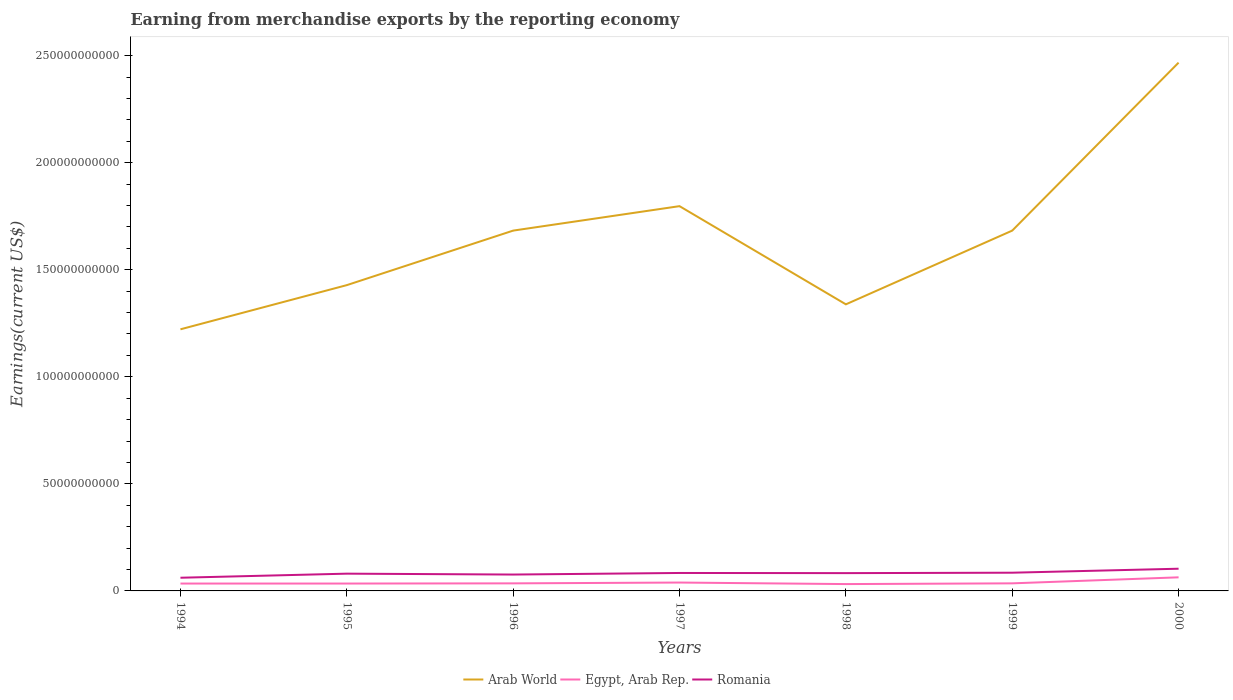How many different coloured lines are there?
Give a very brief answer. 3. Is the number of lines equal to the number of legend labels?
Give a very brief answer. Yes. Across all years, what is the maximum amount earned from merchandise exports in Romania?
Keep it short and to the point. 6.16e+09. In which year was the amount earned from merchandise exports in Arab World maximum?
Offer a very short reply. 1994. What is the total amount earned from merchandise exports in Romania in the graph?
Your answer should be very brief. -6.70e+08. What is the difference between the highest and the second highest amount earned from merchandise exports in Romania?
Offer a very short reply. 4.21e+09. Is the amount earned from merchandise exports in Romania strictly greater than the amount earned from merchandise exports in Arab World over the years?
Keep it short and to the point. Yes. How many years are there in the graph?
Your response must be concise. 7. Does the graph contain any zero values?
Your response must be concise. No. What is the title of the graph?
Your answer should be very brief. Earning from merchandise exports by the reporting economy. What is the label or title of the X-axis?
Offer a terse response. Years. What is the label or title of the Y-axis?
Provide a short and direct response. Earnings(current US$). What is the Earnings(current US$) of Arab World in 1994?
Your answer should be compact. 1.22e+11. What is the Earnings(current US$) of Egypt, Arab Rep. in 1994?
Offer a very short reply. 3.45e+09. What is the Earnings(current US$) in Romania in 1994?
Your answer should be compact. 6.16e+09. What is the Earnings(current US$) of Arab World in 1995?
Your answer should be compact. 1.43e+11. What is the Earnings(current US$) in Egypt, Arab Rep. in 1995?
Ensure brevity in your answer.  3.44e+09. What is the Earnings(current US$) of Romania in 1995?
Give a very brief answer. 8.06e+09. What is the Earnings(current US$) in Arab World in 1996?
Provide a succinct answer. 1.68e+11. What is the Earnings(current US$) of Egypt, Arab Rep. in 1996?
Your response must be concise. 3.53e+09. What is the Earnings(current US$) in Romania in 1996?
Keep it short and to the point. 7.64e+09. What is the Earnings(current US$) in Arab World in 1997?
Keep it short and to the point. 1.80e+11. What is the Earnings(current US$) in Egypt, Arab Rep. in 1997?
Offer a terse response. 3.91e+09. What is the Earnings(current US$) of Romania in 1997?
Offer a very short reply. 8.39e+09. What is the Earnings(current US$) of Arab World in 1998?
Keep it short and to the point. 1.34e+11. What is the Earnings(current US$) in Egypt, Arab Rep. in 1998?
Provide a short and direct response. 3.20e+09. What is the Earnings(current US$) of Romania in 1998?
Keep it short and to the point. 8.31e+09. What is the Earnings(current US$) of Arab World in 1999?
Offer a very short reply. 1.68e+11. What is the Earnings(current US$) of Egypt, Arab Rep. in 1999?
Your answer should be very brief. 3.54e+09. What is the Earnings(current US$) of Romania in 1999?
Keep it short and to the point. 8.51e+09. What is the Earnings(current US$) in Arab World in 2000?
Your answer should be compact. 2.47e+11. What is the Earnings(current US$) in Egypt, Arab Rep. in 2000?
Keep it short and to the point. 6.35e+09. What is the Earnings(current US$) in Romania in 2000?
Give a very brief answer. 1.04e+1. Across all years, what is the maximum Earnings(current US$) of Arab World?
Offer a terse response. 2.47e+11. Across all years, what is the maximum Earnings(current US$) in Egypt, Arab Rep.?
Your answer should be very brief. 6.35e+09. Across all years, what is the maximum Earnings(current US$) of Romania?
Provide a short and direct response. 1.04e+1. Across all years, what is the minimum Earnings(current US$) in Arab World?
Make the answer very short. 1.22e+11. Across all years, what is the minimum Earnings(current US$) of Egypt, Arab Rep.?
Keep it short and to the point. 3.20e+09. Across all years, what is the minimum Earnings(current US$) of Romania?
Ensure brevity in your answer.  6.16e+09. What is the total Earnings(current US$) in Arab World in the graph?
Offer a terse response. 1.16e+12. What is the total Earnings(current US$) of Egypt, Arab Rep. in the graph?
Provide a succinct answer. 2.74e+1. What is the total Earnings(current US$) in Romania in the graph?
Give a very brief answer. 5.74e+1. What is the difference between the Earnings(current US$) of Arab World in 1994 and that in 1995?
Provide a short and direct response. -2.06e+1. What is the difference between the Earnings(current US$) in Egypt, Arab Rep. in 1994 and that in 1995?
Provide a succinct answer. 3.36e+06. What is the difference between the Earnings(current US$) in Romania in 1994 and that in 1995?
Provide a short and direct response. -1.90e+09. What is the difference between the Earnings(current US$) of Arab World in 1994 and that in 1996?
Your answer should be compact. -4.61e+1. What is the difference between the Earnings(current US$) in Egypt, Arab Rep. in 1994 and that in 1996?
Provide a succinct answer. -8.70e+07. What is the difference between the Earnings(current US$) of Romania in 1994 and that in 1996?
Make the answer very short. -1.48e+09. What is the difference between the Earnings(current US$) of Arab World in 1994 and that in 1997?
Offer a terse response. -5.75e+1. What is the difference between the Earnings(current US$) in Egypt, Arab Rep. in 1994 and that in 1997?
Keep it short and to the point. -4.60e+08. What is the difference between the Earnings(current US$) of Romania in 1994 and that in 1997?
Make the answer very short. -2.23e+09. What is the difference between the Earnings(current US$) in Arab World in 1994 and that in 1998?
Offer a very short reply. -1.17e+1. What is the difference between the Earnings(current US$) of Egypt, Arab Rep. in 1994 and that in 1998?
Make the answer very short. 2.52e+08. What is the difference between the Earnings(current US$) in Romania in 1994 and that in 1998?
Ensure brevity in your answer.  -2.15e+09. What is the difference between the Earnings(current US$) in Arab World in 1994 and that in 1999?
Your answer should be very brief. -4.61e+1. What is the difference between the Earnings(current US$) of Egypt, Arab Rep. in 1994 and that in 1999?
Provide a short and direct response. -8.83e+07. What is the difference between the Earnings(current US$) in Romania in 1994 and that in 1999?
Your answer should be compact. -2.35e+09. What is the difference between the Earnings(current US$) in Arab World in 1994 and that in 2000?
Provide a succinct answer. -1.25e+11. What is the difference between the Earnings(current US$) of Egypt, Arab Rep. in 1994 and that in 2000?
Your answer should be compact. -2.90e+09. What is the difference between the Earnings(current US$) in Romania in 1994 and that in 2000?
Keep it short and to the point. -4.21e+09. What is the difference between the Earnings(current US$) of Arab World in 1995 and that in 1996?
Keep it short and to the point. -2.55e+1. What is the difference between the Earnings(current US$) of Egypt, Arab Rep. in 1995 and that in 1996?
Offer a terse response. -9.03e+07. What is the difference between the Earnings(current US$) of Romania in 1995 and that in 1996?
Provide a succinct answer. 4.17e+08. What is the difference between the Earnings(current US$) of Arab World in 1995 and that in 1997?
Provide a short and direct response. -3.69e+1. What is the difference between the Earnings(current US$) of Egypt, Arab Rep. in 1995 and that in 1997?
Offer a terse response. -4.64e+08. What is the difference between the Earnings(current US$) in Romania in 1995 and that in 1997?
Keep it short and to the point. -3.26e+08. What is the difference between the Earnings(current US$) in Arab World in 1995 and that in 1998?
Provide a succinct answer. 8.97e+09. What is the difference between the Earnings(current US$) in Egypt, Arab Rep. in 1995 and that in 1998?
Offer a terse response. 2.49e+08. What is the difference between the Earnings(current US$) in Romania in 1995 and that in 1998?
Keep it short and to the point. -2.53e+08. What is the difference between the Earnings(current US$) of Arab World in 1995 and that in 1999?
Your response must be concise. -2.55e+1. What is the difference between the Earnings(current US$) in Egypt, Arab Rep. in 1995 and that in 1999?
Provide a short and direct response. -9.17e+07. What is the difference between the Earnings(current US$) in Romania in 1995 and that in 1999?
Provide a short and direct response. -4.48e+08. What is the difference between the Earnings(current US$) of Arab World in 1995 and that in 2000?
Offer a terse response. -1.04e+11. What is the difference between the Earnings(current US$) in Egypt, Arab Rep. in 1995 and that in 2000?
Your answer should be very brief. -2.91e+09. What is the difference between the Earnings(current US$) in Romania in 1995 and that in 2000?
Keep it short and to the point. -2.31e+09. What is the difference between the Earnings(current US$) in Arab World in 1996 and that in 1997?
Ensure brevity in your answer.  -1.14e+1. What is the difference between the Earnings(current US$) of Egypt, Arab Rep. in 1996 and that in 1997?
Provide a succinct answer. -3.73e+08. What is the difference between the Earnings(current US$) in Romania in 1996 and that in 1997?
Provide a short and direct response. -7.42e+08. What is the difference between the Earnings(current US$) of Arab World in 1996 and that in 1998?
Give a very brief answer. 3.44e+1. What is the difference between the Earnings(current US$) of Egypt, Arab Rep. in 1996 and that in 1998?
Ensure brevity in your answer.  3.39e+08. What is the difference between the Earnings(current US$) of Romania in 1996 and that in 1998?
Your answer should be very brief. -6.70e+08. What is the difference between the Earnings(current US$) in Arab World in 1996 and that in 1999?
Ensure brevity in your answer.  -3.85e+06. What is the difference between the Earnings(current US$) in Egypt, Arab Rep. in 1996 and that in 1999?
Make the answer very short. -1.32e+06. What is the difference between the Earnings(current US$) in Romania in 1996 and that in 1999?
Make the answer very short. -8.65e+08. What is the difference between the Earnings(current US$) of Arab World in 1996 and that in 2000?
Your response must be concise. -7.84e+1. What is the difference between the Earnings(current US$) of Egypt, Arab Rep. in 1996 and that in 2000?
Your answer should be very brief. -2.82e+09. What is the difference between the Earnings(current US$) of Romania in 1996 and that in 2000?
Offer a terse response. -2.72e+09. What is the difference between the Earnings(current US$) of Arab World in 1997 and that in 1998?
Provide a short and direct response. 4.59e+1. What is the difference between the Earnings(current US$) in Egypt, Arab Rep. in 1997 and that in 1998?
Your answer should be very brief. 7.13e+08. What is the difference between the Earnings(current US$) in Romania in 1997 and that in 1998?
Ensure brevity in your answer.  7.20e+07. What is the difference between the Earnings(current US$) of Arab World in 1997 and that in 1999?
Give a very brief answer. 1.14e+1. What is the difference between the Earnings(current US$) in Egypt, Arab Rep. in 1997 and that in 1999?
Your response must be concise. 3.72e+08. What is the difference between the Earnings(current US$) of Romania in 1997 and that in 1999?
Provide a short and direct response. -1.22e+08. What is the difference between the Earnings(current US$) in Arab World in 1997 and that in 2000?
Provide a succinct answer. -6.70e+1. What is the difference between the Earnings(current US$) in Egypt, Arab Rep. in 1997 and that in 2000?
Your answer should be compact. -2.44e+09. What is the difference between the Earnings(current US$) in Romania in 1997 and that in 2000?
Your response must be concise. -1.98e+09. What is the difference between the Earnings(current US$) in Arab World in 1998 and that in 1999?
Offer a very short reply. -3.44e+1. What is the difference between the Earnings(current US$) in Egypt, Arab Rep. in 1998 and that in 1999?
Your response must be concise. -3.41e+08. What is the difference between the Earnings(current US$) of Romania in 1998 and that in 1999?
Your answer should be very brief. -1.94e+08. What is the difference between the Earnings(current US$) in Arab World in 1998 and that in 2000?
Your answer should be very brief. -1.13e+11. What is the difference between the Earnings(current US$) in Egypt, Arab Rep. in 1998 and that in 2000?
Give a very brief answer. -3.15e+09. What is the difference between the Earnings(current US$) in Romania in 1998 and that in 2000?
Give a very brief answer. -2.05e+09. What is the difference between the Earnings(current US$) in Arab World in 1999 and that in 2000?
Give a very brief answer. -7.84e+1. What is the difference between the Earnings(current US$) of Egypt, Arab Rep. in 1999 and that in 2000?
Your answer should be very brief. -2.81e+09. What is the difference between the Earnings(current US$) in Romania in 1999 and that in 2000?
Make the answer very short. -1.86e+09. What is the difference between the Earnings(current US$) in Arab World in 1994 and the Earnings(current US$) in Egypt, Arab Rep. in 1995?
Provide a short and direct response. 1.19e+11. What is the difference between the Earnings(current US$) of Arab World in 1994 and the Earnings(current US$) of Romania in 1995?
Ensure brevity in your answer.  1.14e+11. What is the difference between the Earnings(current US$) of Egypt, Arab Rep. in 1994 and the Earnings(current US$) of Romania in 1995?
Keep it short and to the point. -4.61e+09. What is the difference between the Earnings(current US$) of Arab World in 1994 and the Earnings(current US$) of Egypt, Arab Rep. in 1996?
Provide a succinct answer. 1.19e+11. What is the difference between the Earnings(current US$) of Arab World in 1994 and the Earnings(current US$) of Romania in 1996?
Keep it short and to the point. 1.15e+11. What is the difference between the Earnings(current US$) in Egypt, Arab Rep. in 1994 and the Earnings(current US$) in Romania in 1996?
Provide a short and direct response. -4.20e+09. What is the difference between the Earnings(current US$) in Arab World in 1994 and the Earnings(current US$) in Egypt, Arab Rep. in 1997?
Your answer should be very brief. 1.18e+11. What is the difference between the Earnings(current US$) of Arab World in 1994 and the Earnings(current US$) of Romania in 1997?
Offer a terse response. 1.14e+11. What is the difference between the Earnings(current US$) in Egypt, Arab Rep. in 1994 and the Earnings(current US$) in Romania in 1997?
Provide a succinct answer. -4.94e+09. What is the difference between the Earnings(current US$) of Arab World in 1994 and the Earnings(current US$) of Egypt, Arab Rep. in 1998?
Give a very brief answer. 1.19e+11. What is the difference between the Earnings(current US$) in Arab World in 1994 and the Earnings(current US$) in Romania in 1998?
Your answer should be very brief. 1.14e+11. What is the difference between the Earnings(current US$) in Egypt, Arab Rep. in 1994 and the Earnings(current US$) in Romania in 1998?
Offer a very short reply. -4.87e+09. What is the difference between the Earnings(current US$) in Arab World in 1994 and the Earnings(current US$) in Egypt, Arab Rep. in 1999?
Ensure brevity in your answer.  1.19e+11. What is the difference between the Earnings(current US$) of Arab World in 1994 and the Earnings(current US$) of Romania in 1999?
Offer a terse response. 1.14e+11. What is the difference between the Earnings(current US$) of Egypt, Arab Rep. in 1994 and the Earnings(current US$) of Romania in 1999?
Make the answer very short. -5.06e+09. What is the difference between the Earnings(current US$) of Arab World in 1994 and the Earnings(current US$) of Egypt, Arab Rep. in 2000?
Provide a succinct answer. 1.16e+11. What is the difference between the Earnings(current US$) in Arab World in 1994 and the Earnings(current US$) in Romania in 2000?
Keep it short and to the point. 1.12e+11. What is the difference between the Earnings(current US$) in Egypt, Arab Rep. in 1994 and the Earnings(current US$) in Romania in 2000?
Make the answer very short. -6.92e+09. What is the difference between the Earnings(current US$) in Arab World in 1995 and the Earnings(current US$) in Egypt, Arab Rep. in 1996?
Your answer should be very brief. 1.39e+11. What is the difference between the Earnings(current US$) in Arab World in 1995 and the Earnings(current US$) in Romania in 1996?
Provide a short and direct response. 1.35e+11. What is the difference between the Earnings(current US$) in Egypt, Arab Rep. in 1995 and the Earnings(current US$) in Romania in 1996?
Your answer should be compact. -4.20e+09. What is the difference between the Earnings(current US$) of Arab World in 1995 and the Earnings(current US$) of Egypt, Arab Rep. in 1997?
Offer a very short reply. 1.39e+11. What is the difference between the Earnings(current US$) in Arab World in 1995 and the Earnings(current US$) in Romania in 1997?
Your response must be concise. 1.34e+11. What is the difference between the Earnings(current US$) of Egypt, Arab Rep. in 1995 and the Earnings(current US$) of Romania in 1997?
Provide a short and direct response. -4.94e+09. What is the difference between the Earnings(current US$) of Arab World in 1995 and the Earnings(current US$) of Egypt, Arab Rep. in 1998?
Keep it short and to the point. 1.40e+11. What is the difference between the Earnings(current US$) of Arab World in 1995 and the Earnings(current US$) of Romania in 1998?
Keep it short and to the point. 1.34e+11. What is the difference between the Earnings(current US$) of Egypt, Arab Rep. in 1995 and the Earnings(current US$) of Romania in 1998?
Ensure brevity in your answer.  -4.87e+09. What is the difference between the Earnings(current US$) of Arab World in 1995 and the Earnings(current US$) of Egypt, Arab Rep. in 1999?
Provide a short and direct response. 1.39e+11. What is the difference between the Earnings(current US$) of Arab World in 1995 and the Earnings(current US$) of Romania in 1999?
Make the answer very short. 1.34e+11. What is the difference between the Earnings(current US$) in Egypt, Arab Rep. in 1995 and the Earnings(current US$) in Romania in 1999?
Keep it short and to the point. -5.06e+09. What is the difference between the Earnings(current US$) of Arab World in 1995 and the Earnings(current US$) of Egypt, Arab Rep. in 2000?
Provide a succinct answer. 1.36e+11. What is the difference between the Earnings(current US$) in Arab World in 1995 and the Earnings(current US$) in Romania in 2000?
Your answer should be very brief. 1.32e+11. What is the difference between the Earnings(current US$) in Egypt, Arab Rep. in 1995 and the Earnings(current US$) in Romania in 2000?
Your response must be concise. -6.92e+09. What is the difference between the Earnings(current US$) of Arab World in 1996 and the Earnings(current US$) of Egypt, Arab Rep. in 1997?
Offer a very short reply. 1.64e+11. What is the difference between the Earnings(current US$) in Arab World in 1996 and the Earnings(current US$) in Romania in 1997?
Ensure brevity in your answer.  1.60e+11. What is the difference between the Earnings(current US$) of Egypt, Arab Rep. in 1996 and the Earnings(current US$) of Romania in 1997?
Ensure brevity in your answer.  -4.85e+09. What is the difference between the Earnings(current US$) of Arab World in 1996 and the Earnings(current US$) of Egypt, Arab Rep. in 1998?
Give a very brief answer. 1.65e+11. What is the difference between the Earnings(current US$) of Arab World in 1996 and the Earnings(current US$) of Romania in 1998?
Your answer should be very brief. 1.60e+11. What is the difference between the Earnings(current US$) of Egypt, Arab Rep. in 1996 and the Earnings(current US$) of Romania in 1998?
Provide a succinct answer. -4.78e+09. What is the difference between the Earnings(current US$) in Arab World in 1996 and the Earnings(current US$) in Egypt, Arab Rep. in 1999?
Offer a terse response. 1.65e+11. What is the difference between the Earnings(current US$) of Arab World in 1996 and the Earnings(current US$) of Romania in 1999?
Your answer should be very brief. 1.60e+11. What is the difference between the Earnings(current US$) in Egypt, Arab Rep. in 1996 and the Earnings(current US$) in Romania in 1999?
Your answer should be compact. -4.97e+09. What is the difference between the Earnings(current US$) of Arab World in 1996 and the Earnings(current US$) of Egypt, Arab Rep. in 2000?
Your response must be concise. 1.62e+11. What is the difference between the Earnings(current US$) in Arab World in 1996 and the Earnings(current US$) in Romania in 2000?
Offer a very short reply. 1.58e+11. What is the difference between the Earnings(current US$) of Egypt, Arab Rep. in 1996 and the Earnings(current US$) of Romania in 2000?
Ensure brevity in your answer.  -6.83e+09. What is the difference between the Earnings(current US$) in Arab World in 1997 and the Earnings(current US$) in Egypt, Arab Rep. in 1998?
Provide a succinct answer. 1.77e+11. What is the difference between the Earnings(current US$) in Arab World in 1997 and the Earnings(current US$) in Romania in 1998?
Provide a succinct answer. 1.71e+11. What is the difference between the Earnings(current US$) in Egypt, Arab Rep. in 1997 and the Earnings(current US$) in Romania in 1998?
Keep it short and to the point. -4.41e+09. What is the difference between the Earnings(current US$) of Arab World in 1997 and the Earnings(current US$) of Egypt, Arab Rep. in 1999?
Provide a short and direct response. 1.76e+11. What is the difference between the Earnings(current US$) of Arab World in 1997 and the Earnings(current US$) of Romania in 1999?
Provide a succinct answer. 1.71e+11. What is the difference between the Earnings(current US$) of Egypt, Arab Rep. in 1997 and the Earnings(current US$) of Romania in 1999?
Give a very brief answer. -4.60e+09. What is the difference between the Earnings(current US$) of Arab World in 1997 and the Earnings(current US$) of Egypt, Arab Rep. in 2000?
Offer a terse response. 1.73e+11. What is the difference between the Earnings(current US$) of Arab World in 1997 and the Earnings(current US$) of Romania in 2000?
Ensure brevity in your answer.  1.69e+11. What is the difference between the Earnings(current US$) in Egypt, Arab Rep. in 1997 and the Earnings(current US$) in Romania in 2000?
Provide a succinct answer. -6.46e+09. What is the difference between the Earnings(current US$) of Arab World in 1998 and the Earnings(current US$) of Egypt, Arab Rep. in 1999?
Provide a succinct answer. 1.30e+11. What is the difference between the Earnings(current US$) in Arab World in 1998 and the Earnings(current US$) in Romania in 1999?
Your answer should be very brief. 1.25e+11. What is the difference between the Earnings(current US$) of Egypt, Arab Rep. in 1998 and the Earnings(current US$) of Romania in 1999?
Offer a very short reply. -5.31e+09. What is the difference between the Earnings(current US$) of Arab World in 1998 and the Earnings(current US$) of Egypt, Arab Rep. in 2000?
Offer a very short reply. 1.27e+11. What is the difference between the Earnings(current US$) in Arab World in 1998 and the Earnings(current US$) in Romania in 2000?
Keep it short and to the point. 1.23e+11. What is the difference between the Earnings(current US$) in Egypt, Arab Rep. in 1998 and the Earnings(current US$) in Romania in 2000?
Your response must be concise. -7.17e+09. What is the difference between the Earnings(current US$) in Arab World in 1999 and the Earnings(current US$) in Egypt, Arab Rep. in 2000?
Ensure brevity in your answer.  1.62e+11. What is the difference between the Earnings(current US$) of Arab World in 1999 and the Earnings(current US$) of Romania in 2000?
Offer a very short reply. 1.58e+11. What is the difference between the Earnings(current US$) of Egypt, Arab Rep. in 1999 and the Earnings(current US$) of Romania in 2000?
Offer a terse response. -6.83e+09. What is the average Earnings(current US$) of Arab World per year?
Give a very brief answer. 1.66e+11. What is the average Earnings(current US$) of Egypt, Arab Rep. per year?
Give a very brief answer. 3.92e+09. What is the average Earnings(current US$) of Romania per year?
Provide a succinct answer. 8.21e+09. In the year 1994, what is the difference between the Earnings(current US$) of Arab World and Earnings(current US$) of Egypt, Arab Rep.?
Provide a short and direct response. 1.19e+11. In the year 1994, what is the difference between the Earnings(current US$) of Arab World and Earnings(current US$) of Romania?
Ensure brevity in your answer.  1.16e+11. In the year 1994, what is the difference between the Earnings(current US$) of Egypt, Arab Rep. and Earnings(current US$) of Romania?
Your response must be concise. -2.71e+09. In the year 1995, what is the difference between the Earnings(current US$) in Arab World and Earnings(current US$) in Egypt, Arab Rep.?
Give a very brief answer. 1.39e+11. In the year 1995, what is the difference between the Earnings(current US$) in Arab World and Earnings(current US$) in Romania?
Ensure brevity in your answer.  1.35e+11. In the year 1995, what is the difference between the Earnings(current US$) in Egypt, Arab Rep. and Earnings(current US$) in Romania?
Provide a short and direct response. -4.62e+09. In the year 1996, what is the difference between the Earnings(current US$) of Arab World and Earnings(current US$) of Egypt, Arab Rep.?
Your answer should be very brief. 1.65e+11. In the year 1996, what is the difference between the Earnings(current US$) in Arab World and Earnings(current US$) in Romania?
Make the answer very short. 1.61e+11. In the year 1996, what is the difference between the Earnings(current US$) in Egypt, Arab Rep. and Earnings(current US$) in Romania?
Provide a succinct answer. -4.11e+09. In the year 1997, what is the difference between the Earnings(current US$) of Arab World and Earnings(current US$) of Egypt, Arab Rep.?
Your answer should be compact. 1.76e+11. In the year 1997, what is the difference between the Earnings(current US$) in Arab World and Earnings(current US$) in Romania?
Your response must be concise. 1.71e+11. In the year 1997, what is the difference between the Earnings(current US$) in Egypt, Arab Rep. and Earnings(current US$) in Romania?
Give a very brief answer. -4.48e+09. In the year 1998, what is the difference between the Earnings(current US$) in Arab World and Earnings(current US$) in Egypt, Arab Rep.?
Offer a very short reply. 1.31e+11. In the year 1998, what is the difference between the Earnings(current US$) of Arab World and Earnings(current US$) of Romania?
Make the answer very short. 1.26e+11. In the year 1998, what is the difference between the Earnings(current US$) in Egypt, Arab Rep. and Earnings(current US$) in Romania?
Offer a very short reply. -5.12e+09. In the year 1999, what is the difference between the Earnings(current US$) of Arab World and Earnings(current US$) of Egypt, Arab Rep.?
Provide a succinct answer. 1.65e+11. In the year 1999, what is the difference between the Earnings(current US$) in Arab World and Earnings(current US$) in Romania?
Provide a short and direct response. 1.60e+11. In the year 1999, what is the difference between the Earnings(current US$) in Egypt, Arab Rep. and Earnings(current US$) in Romania?
Keep it short and to the point. -4.97e+09. In the year 2000, what is the difference between the Earnings(current US$) of Arab World and Earnings(current US$) of Egypt, Arab Rep.?
Keep it short and to the point. 2.40e+11. In the year 2000, what is the difference between the Earnings(current US$) of Arab World and Earnings(current US$) of Romania?
Your answer should be compact. 2.36e+11. In the year 2000, what is the difference between the Earnings(current US$) in Egypt, Arab Rep. and Earnings(current US$) in Romania?
Your answer should be compact. -4.02e+09. What is the ratio of the Earnings(current US$) of Arab World in 1994 to that in 1995?
Keep it short and to the point. 0.86. What is the ratio of the Earnings(current US$) in Egypt, Arab Rep. in 1994 to that in 1995?
Provide a short and direct response. 1. What is the ratio of the Earnings(current US$) in Romania in 1994 to that in 1995?
Offer a terse response. 0.76. What is the ratio of the Earnings(current US$) in Arab World in 1994 to that in 1996?
Give a very brief answer. 0.73. What is the ratio of the Earnings(current US$) of Egypt, Arab Rep. in 1994 to that in 1996?
Your answer should be very brief. 0.98. What is the ratio of the Earnings(current US$) in Romania in 1994 to that in 1996?
Your response must be concise. 0.81. What is the ratio of the Earnings(current US$) in Arab World in 1994 to that in 1997?
Offer a very short reply. 0.68. What is the ratio of the Earnings(current US$) of Egypt, Arab Rep. in 1994 to that in 1997?
Your response must be concise. 0.88. What is the ratio of the Earnings(current US$) of Romania in 1994 to that in 1997?
Your response must be concise. 0.73. What is the ratio of the Earnings(current US$) in Arab World in 1994 to that in 1998?
Your response must be concise. 0.91. What is the ratio of the Earnings(current US$) in Egypt, Arab Rep. in 1994 to that in 1998?
Provide a short and direct response. 1.08. What is the ratio of the Earnings(current US$) of Romania in 1994 to that in 1998?
Give a very brief answer. 0.74. What is the ratio of the Earnings(current US$) in Arab World in 1994 to that in 1999?
Provide a succinct answer. 0.73. What is the ratio of the Earnings(current US$) in Romania in 1994 to that in 1999?
Ensure brevity in your answer.  0.72. What is the ratio of the Earnings(current US$) of Arab World in 1994 to that in 2000?
Keep it short and to the point. 0.5. What is the ratio of the Earnings(current US$) of Egypt, Arab Rep. in 1994 to that in 2000?
Offer a very short reply. 0.54. What is the ratio of the Earnings(current US$) in Romania in 1994 to that in 2000?
Offer a very short reply. 0.59. What is the ratio of the Earnings(current US$) in Arab World in 1995 to that in 1996?
Give a very brief answer. 0.85. What is the ratio of the Earnings(current US$) of Egypt, Arab Rep. in 1995 to that in 1996?
Ensure brevity in your answer.  0.97. What is the ratio of the Earnings(current US$) of Romania in 1995 to that in 1996?
Offer a terse response. 1.05. What is the ratio of the Earnings(current US$) in Arab World in 1995 to that in 1997?
Ensure brevity in your answer.  0.79. What is the ratio of the Earnings(current US$) in Egypt, Arab Rep. in 1995 to that in 1997?
Provide a succinct answer. 0.88. What is the ratio of the Earnings(current US$) of Romania in 1995 to that in 1997?
Provide a short and direct response. 0.96. What is the ratio of the Earnings(current US$) in Arab World in 1995 to that in 1998?
Keep it short and to the point. 1.07. What is the ratio of the Earnings(current US$) in Egypt, Arab Rep. in 1995 to that in 1998?
Offer a terse response. 1.08. What is the ratio of the Earnings(current US$) in Romania in 1995 to that in 1998?
Your response must be concise. 0.97. What is the ratio of the Earnings(current US$) in Arab World in 1995 to that in 1999?
Offer a terse response. 0.85. What is the ratio of the Earnings(current US$) in Egypt, Arab Rep. in 1995 to that in 1999?
Offer a terse response. 0.97. What is the ratio of the Earnings(current US$) of Romania in 1995 to that in 1999?
Your answer should be very brief. 0.95. What is the ratio of the Earnings(current US$) of Arab World in 1995 to that in 2000?
Your response must be concise. 0.58. What is the ratio of the Earnings(current US$) in Egypt, Arab Rep. in 1995 to that in 2000?
Keep it short and to the point. 0.54. What is the ratio of the Earnings(current US$) in Romania in 1995 to that in 2000?
Your response must be concise. 0.78. What is the ratio of the Earnings(current US$) in Arab World in 1996 to that in 1997?
Your response must be concise. 0.94. What is the ratio of the Earnings(current US$) of Egypt, Arab Rep. in 1996 to that in 1997?
Ensure brevity in your answer.  0.9. What is the ratio of the Earnings(current US$) of Romania in 1996 to that in 1997?
Give a very brief answer. 0.91. What is the ratio of the Earnings(current US$) of Arab World in 1996 to that in 1998?
Give a very brief answer. 1.26. What is the ratio of the Earnings(current US$) of Egypt, Arab Rep. in 1996 to that in 1998?
Provide a succinct answer. 1.11. What is the ratio of the Earnings(current US$) of Romania in 1996 to that in 1998?
Ensure brevity in your answer.  0.92. What is the ratio of the Earnings(current US$) of Arab World in 1996 to that in 1999?
Offer a very short reply. 1. What is the ratio of the Earnings(current US$) in Egypt, Arab Rep. in 1996 to that in 1999?
Give a very brief answer. 1. What is the ratio of the Earnings(current US$) in Romania in 1996 to that in 1999?
Offer a very short reply. 0.9. What is the ratio of the Earnings(current US$) of Arab World in 1996 to that in 2000?
Your answer should be compact. 0.68. What is the ratio of the Earnings(current US$) in Egypt, Arab Rep. in 1996 to that in 2000?
Your answer should be compact. 0.56. What is the ratio of the Earnings(current US$) of Romania in 1996 to that in 2000?
Your answer should be very brief. 0.74. What is the ratio of the Earnings(current US$) in Arab World in 1997 to that in 1998?
Offer a very short reply. 1.34. What is the ratio of the Earnings(current US$) of Egypt, Arab Rep. in 1997 to that in 1998?
Ensure brevity in your answer.  1.22. What is the ratio of the Earnings(current US$) of Romania in 1997 to that in 1998?
Your answer should be compact. 1.01. What is the ratio of the Earnings(current US$) in Arab World in 1997 to that in 1999?
Keep it short and to the point. 1.07. What is the ratio of the Earnings(current US$) in Egypt, Arab Rep. in 1997 to that in 1999?
Your answer should be compact. 1.11. What is the ratio of the Earnings(current US$) in Romania in 1997 to that in 1999?
Provide a succinct answer. 0.99. What is the ratio of the Earnings(current US$) of Arab World in 1997 to that in 2000?
Ensure brevity in your answer.  0.73. What is the ratio of the Earnings(current US$) in Egypt, Arab Rep. in 1997 to that in 2000?
Make the answer very short. 0.62. What is the ratio of the Earnings(current US$) of Romania in 1997 to that in 2000?
Offer a very short reply. 0.81. What is the ratio of the Earnings(current US$) of Arab World in 1998 to that in 1999?
Offer a very short reply. 0.8. What is the ratio of the Earnings(current US$) of Egypt, Arab Rep. in 1998 to that in 1999?
Provide a short and direct response. 0.9. What is the ratio of the Earnings(current US$) of Romania in 1998 to that in 1999?
Provide a short and direct response. 0.98. What is the ratio of the Earnings(current US$) in Arab World in 1998 to that in 2000?
Give a very brief answer. 0.54. What is the ratio of the Earnings(current US$) in Egypt, Arab Rep. in 1998 to that in 2000?
Make the answer very short. 0.5. What is the ratio of the Earnings(current US$) of Romania in 1998 to that in 2000?
Provide a short and direct response. 0.8. What is the ratio of the Earnings(current US$) of Arab World in 1999 to that in 2000?
Your answer should be very brief. 0.68. What is the ratio of the Earnings(current US$) in Egypt, Arab Rep. in 1999 to that in 2000?
Keep it short and to the point. 0.56. What is the ratio of the Earnings(current US$) of Romania in 1999 to that in 2000?
Your answer should be very brief. 0.82. What is the difference between the highest and the second highest Earnings(current US$) in Arab World?
Provide a succinct answer. 6.70e+1. What is the difference between the highest and the second highest Earnings(current US$) of Egypt, Arab Rep.?
Your answer should be very brief. 2.44e+09. What is the difference between the highest and the second highest Earnings(current US$) in Romania?
Your answer should be compact. 1.86e+09. What is the difference between the highest and the lowest Earnings(current US$) in Arab World?
Offer a terse response. 1.25e+11. What is the difference between the highest and the lowest Earnings(current US$) in Egypt, Arab Rep.?
Give a very brief answer. 3.15e+09. What is the difference between the highest and the lowest Earnings(current US$) of Romania?
Provide a succinct answer. 4.21e+09. 